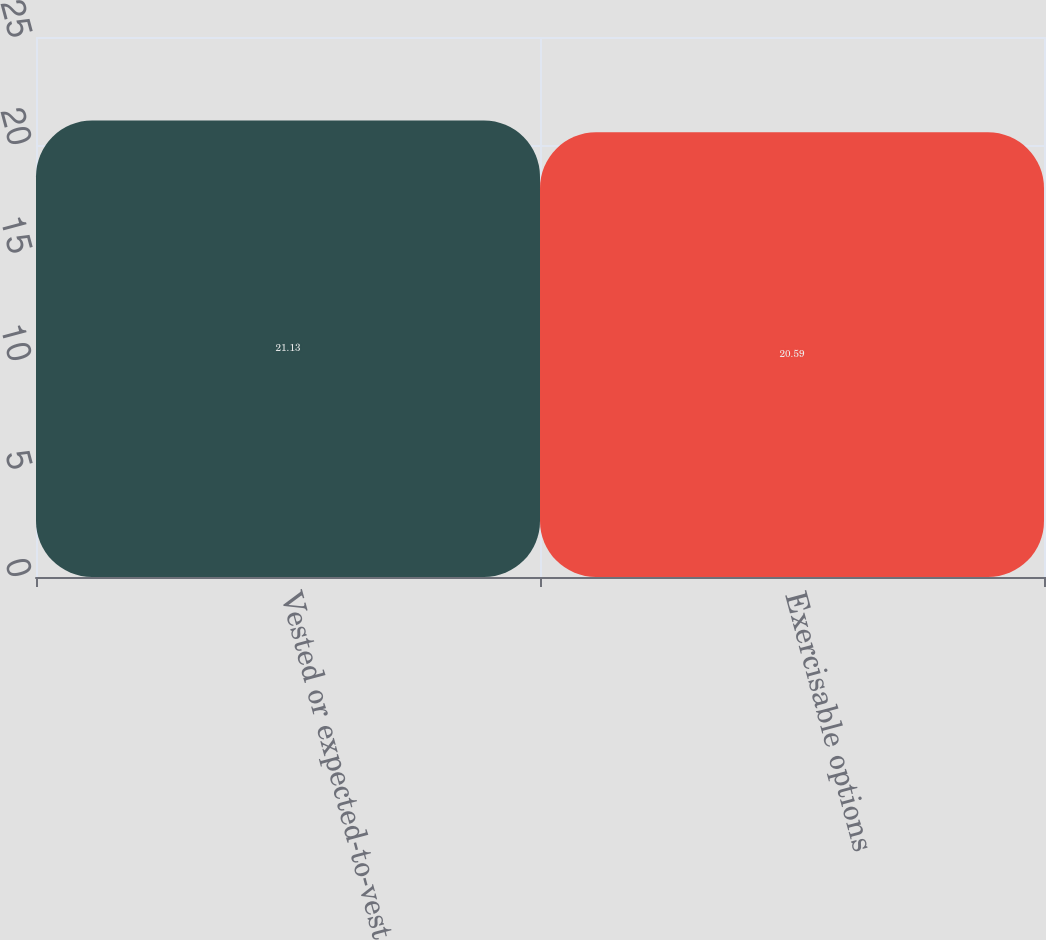Convert chart to OTSL. <chart><loc_0><loc_0><loc_500><loc_500><bar_chart><fcel>Vested or expected-to-vest<fcel>Exercisable options<nl><fcel>21.13<fcel>20.59<nl></chart> 